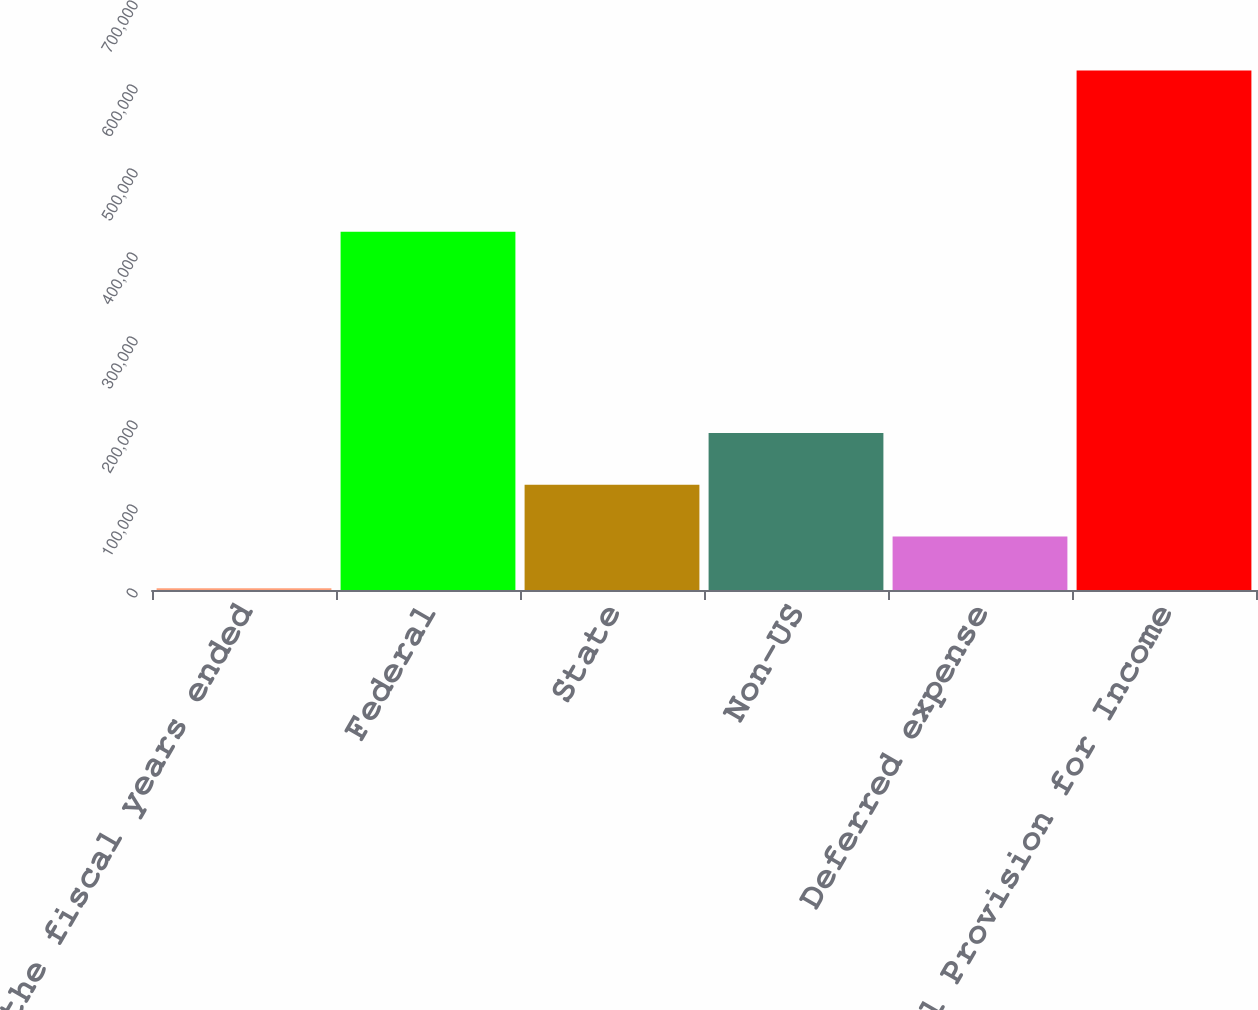<chart> <loc_0><loc_0><loc_500><loc_500><bar_chart><fcel>for the fiscal years ended<fcel>Federal<fcel>State<fcel>Non-US<fcel>Deferred expense<fcel>Total Provision for Income<nl><fcel>2010<fcel>426470<fcel>125270<fcel>186901<fcel>63640.2<fcel>618312<nl></chart> 